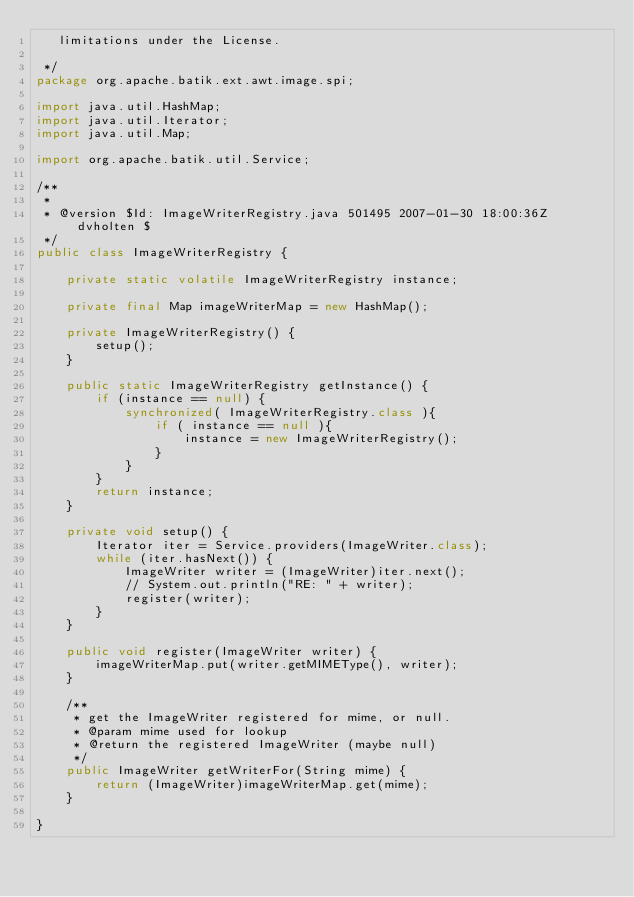Convert code to text. <code><loc_0><loc_0><loc_500><loc_500><_Java_>   limitations under the License.

 */
package org.apache.batik.ext.awt.image.spi;

import java.util.HashMap;
import java.util.Iterator;
import java.util.Map;

import org.apache.batik.util.Service;

/**
 *
 * @version $Id: ImageWriterRegistry.java 501495 2007-01-30 18:00:36Z dvholten $
 */
public class ImageWriterRegistry {

    private static volatile ImageWriterRegistry instance;

    private final Map imageWriterMap = new HashMap();

    private ImageWriterRegistry() {
        setup();
    }

    public static ImageWriterRegistry getInstance() {
        if (instance == null) {
            synchronized( ImageWriterRegistry.class ){
                if ( instance == null ){
                    instance = new ImageWriterRegistry();
                }
            }
        }
        return instance;
    }

    private void setup() {
        Iterator iter = Service.providers(ImageWriter.class);
        while (iter.hasNext()) {
            ImageWriter writer = (ImageWriter)iter.next();
            // System.out.println("RE: " + writer);
            register(writer);
        }
    }

    public void register(ImageWriter writer) {
        imageWriterMap.put(writer.getMIMEType(), writer);
    }

    /**
     * get the ImageWriter registered for mime, or null.
     * @param mime used for lookup
     * @return the registered ImageWriter (maybe null)
     */
    public ImageWriter getWriterFor(String mime) {
        return (ImageWriter)imageWriterMap.get(mime);
    }

}
</code> 